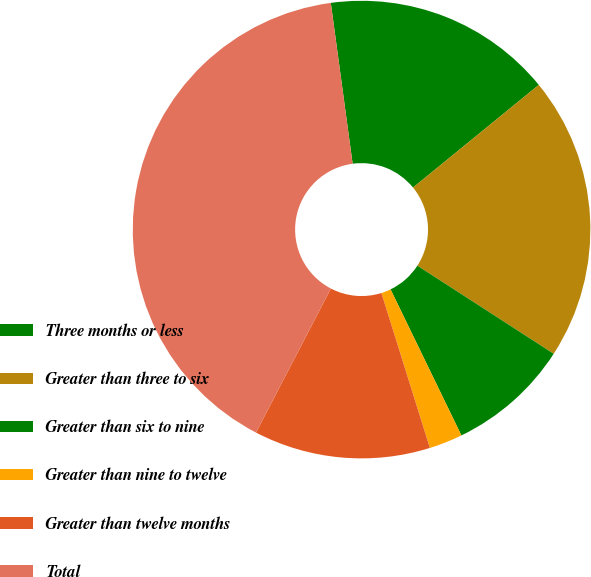<chart> <loc_0><loc_0><loc_500><loc_500><pie_chart><fcel>Three months or less<fcel>Greater than three to six<fcel>Greater than six to nine<fcel>Greater than nine to twelve<fcel>Greater than twelve months<fcel>Total<nl><fcel>16.25%<fcel>20.03%<fcel>8.68%<fcel>2.36%<fcel>12.46%<fcel>40.22%<nl></chart> 